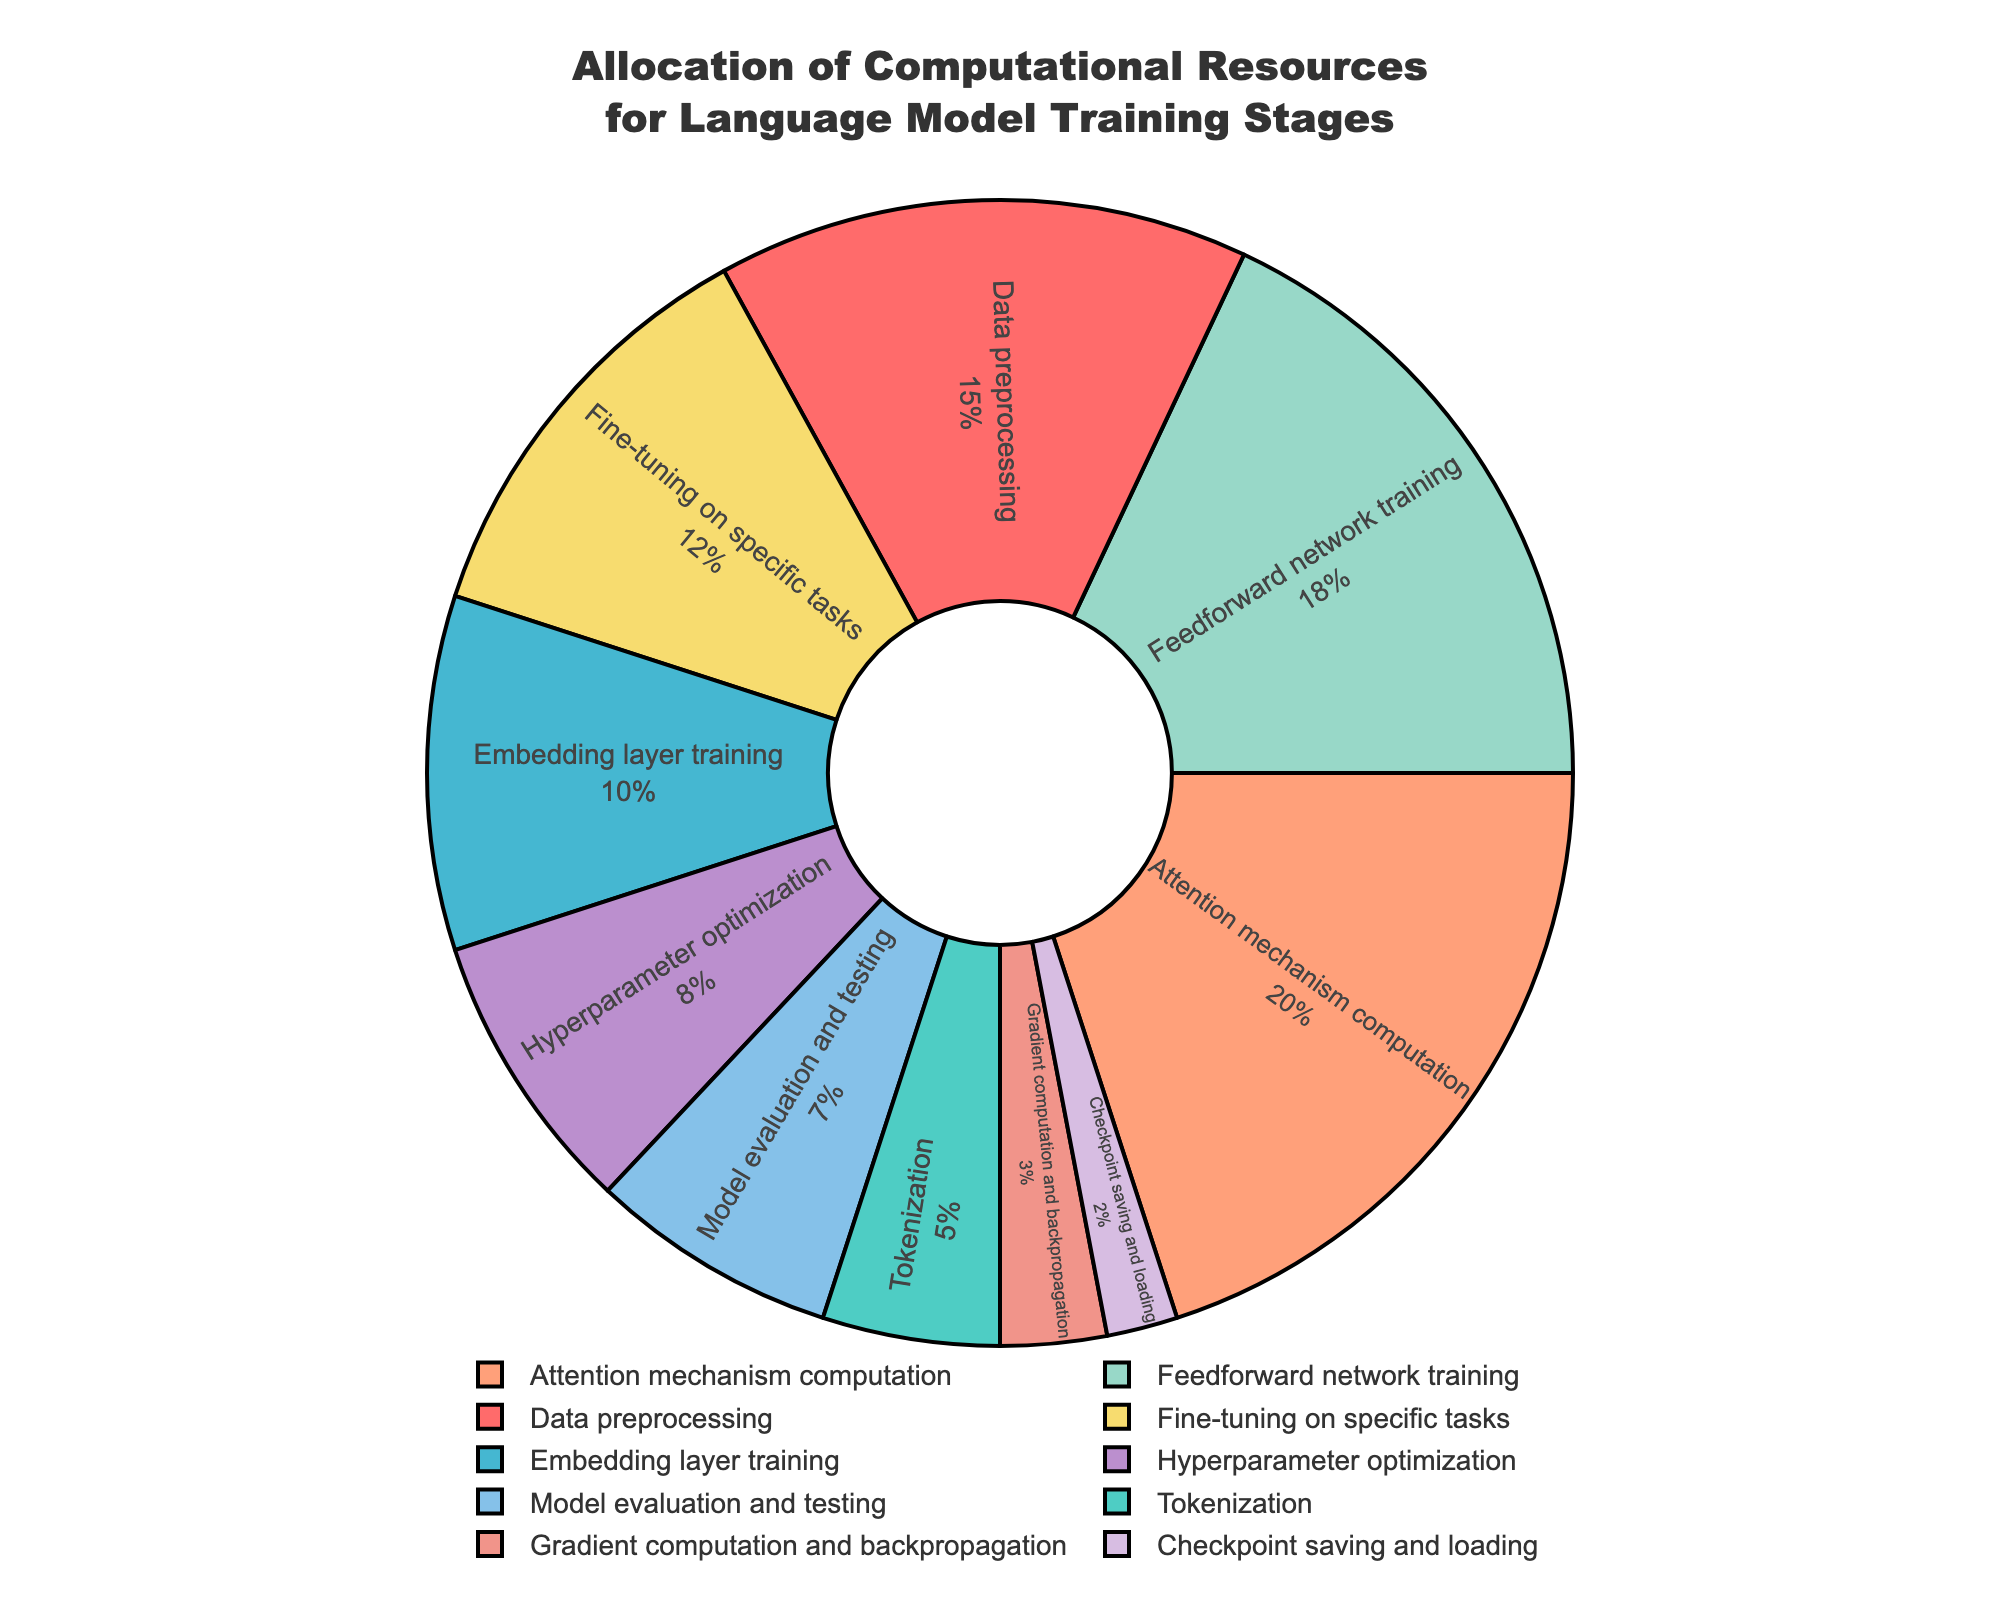What percentage of computational resources is allocated to the attention mechanism computation? Find the section labeled "Attention mechanism computation" in the pie chart and note the percentage value.
Answer: 20% Which training stage receives the smallest allocation of computational resources? Locate the section in the pie chart with the smallest slice, checking the labels to confirm the corresponding stage.
Answer: Checkpoint saving and loading Which stages together account for more than half of the computational resources? Sum the percentages of stages. Check if their total exceeds 50%. For example, adding the highest values first: Attention mechanism computation (20%) + Feedforward network training (18%) + Fine-tuning on specific tasks (12%) = 50%. Keep adding percentages until the sum exceeds 50%.
Answer: Attention mechanism computation, Feedforward network training, Fine-tuning on specific tasks How does the percentage allocated for data preprocessing compare to that for gradient computation and backpropagation? Compare the two percentages: Data preprocessing is 15% while Gradient computation and backpropagation is 3%.
Answer: Data preprocessing is greater What is the total percentage allocation of resources for model evaluation and testing and hyperparameter optimization? Add the percentages for both stages: 7% (Model evaluation and testing) + 8% (Hyperparameter optimization).
Answer: 15% Which stage has nearly double the allocation of tokenization? Find the stage with a percentage approximately twice that of tokenization, which is 5%. The closest is Hyperparameter optimization at 8%, then look for a better match. 10% as seen in Embedding layer training is nearly double.
Answer: Embedding layer training What color is used to represent the stage with the lowest allocation? Identify the color associated with "Checkpoint saving and loading", the section with the smallest slice.
Answer: Purple (lavender or lilac shade) Are the percentages for fine-tuning on specific tasks and data preprocessing more or less equal, combined? Why? Sum both percentages: 12% (Fine-tuning) + 15% (Data preprocessing) = 27%. Evaluate if it's greater, equal to, or less than half of the total (50%).
Answer: Less than half What are the two stages with the least amount of resources allocated together? Identify and sum the percentages of the two smallest slices: Checkpoint saving and loading (2%) + Gradient computation and backpropagation (3%).
Answer: 5% What fraction of the resources is allocated to feedforward network training relative to the total for embedding layer training and hyperparameter optimization combined? Find the fraction: Feedforward network training (18%) divided by the sum of Embedding layer training and Hyperparameter optimization (10% + 8% = 18%).
Answer: 1 (equal) 